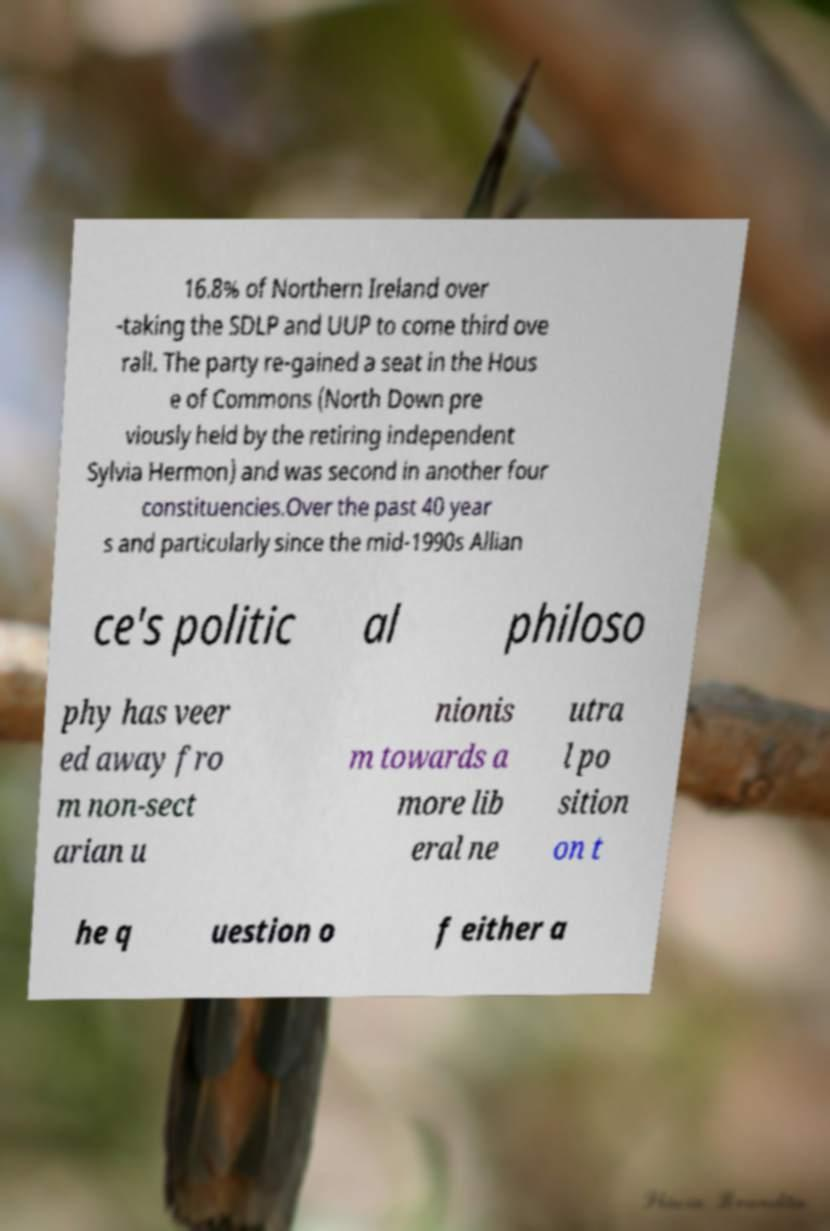What messages or text are displayed in this image? I need them in a readable, typed format. 16.8% of Northern Ireland over -taking the SDLP and UUP to come third ove rall. The party re-gained a seat in the Hous e of Commons (North Down pre viously held by the retiring independent Sylvia Hermon) and was second in another four constituencies.Over the past 40 year s and particularly since the mid-1990s Allian ce's politic al philoso phy has veer ed away fro m non-sect arian u nionis m towards a more lib eral ne utra l po sition on t he q uestion o f either a 